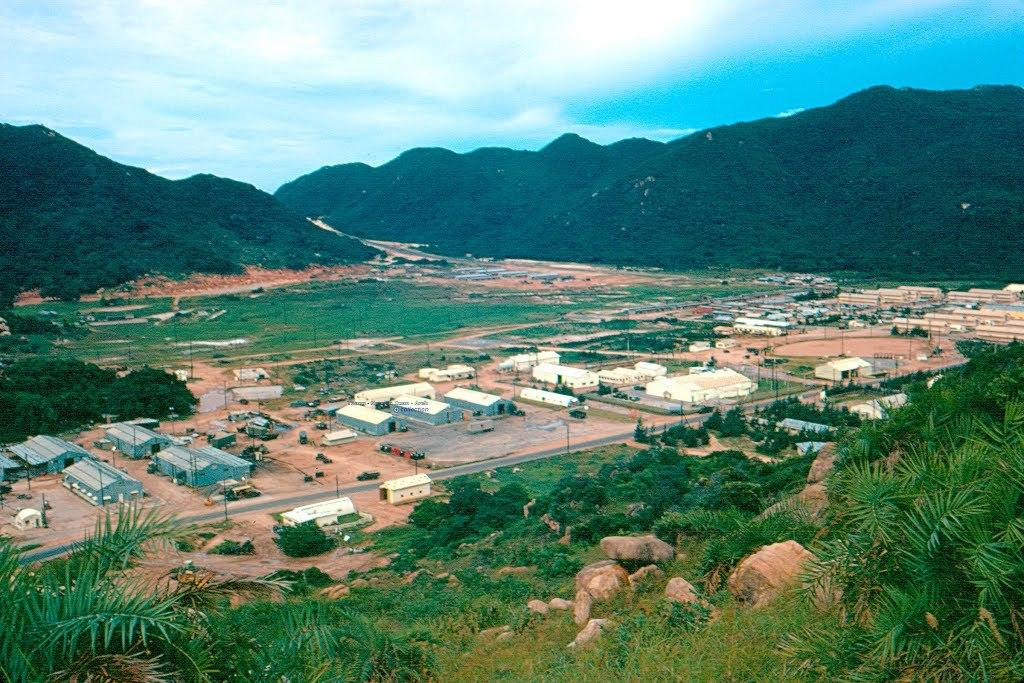What type of vegetation is present in the image? There is grass and trees in the image. What other objects can be seen in the image? There are stones and houses visible in the image. What is visible in the background of the image? There are trees, hills, and the sky visible in the background of the image. Is there any grass visible in the background of the image? Yes, there is grass visible in the background of the image. What type of tin can be seen in the image? There is no tin present in the image. How many feet are visible in the image? There are no feet visible in the image. 